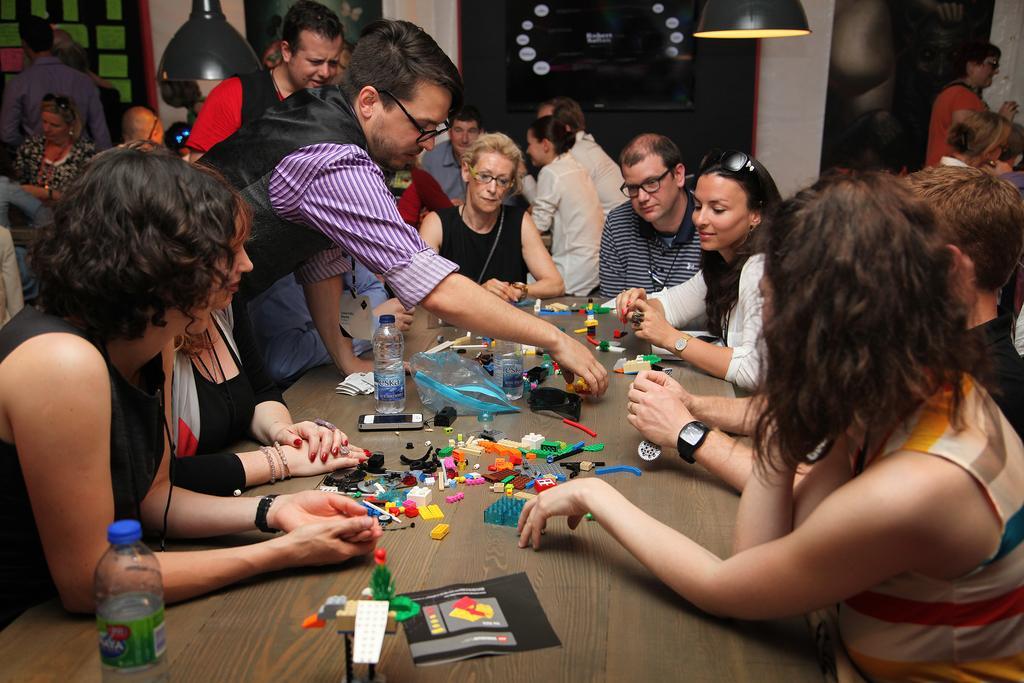Could you give a brief overview of what you see in this image? In this image I see number of people and there are lights over here, I can also see a table on which there are bottles and many other things. 